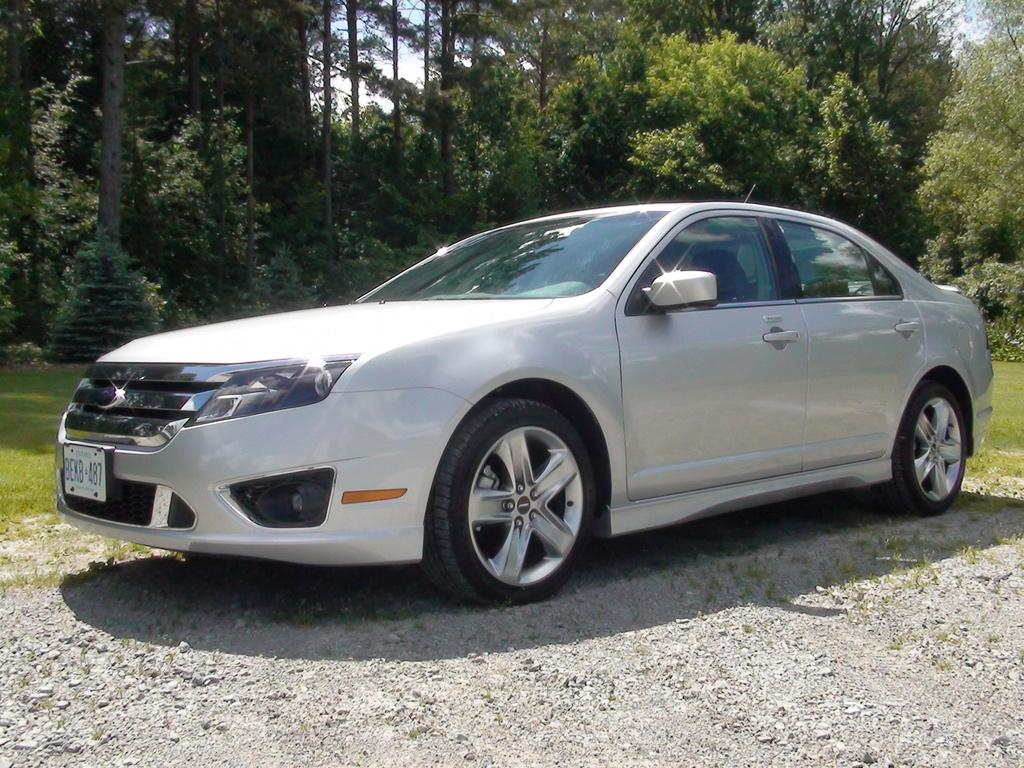What is the main subject of the image? The main subject of the image is a car. Where is the car located in the image? The car is placed on the ground. What can be seen in the background of the image? There is sky, trees, and grass visible in the background of the image. What type of blood is visible on the car's tires in the image? There is no blood visible on the car's tires in the image. Can you tell me how many chairs are present in the image? There are no chairs present in the image; it features a car on the ground with a background of sky, trees, and grass. 